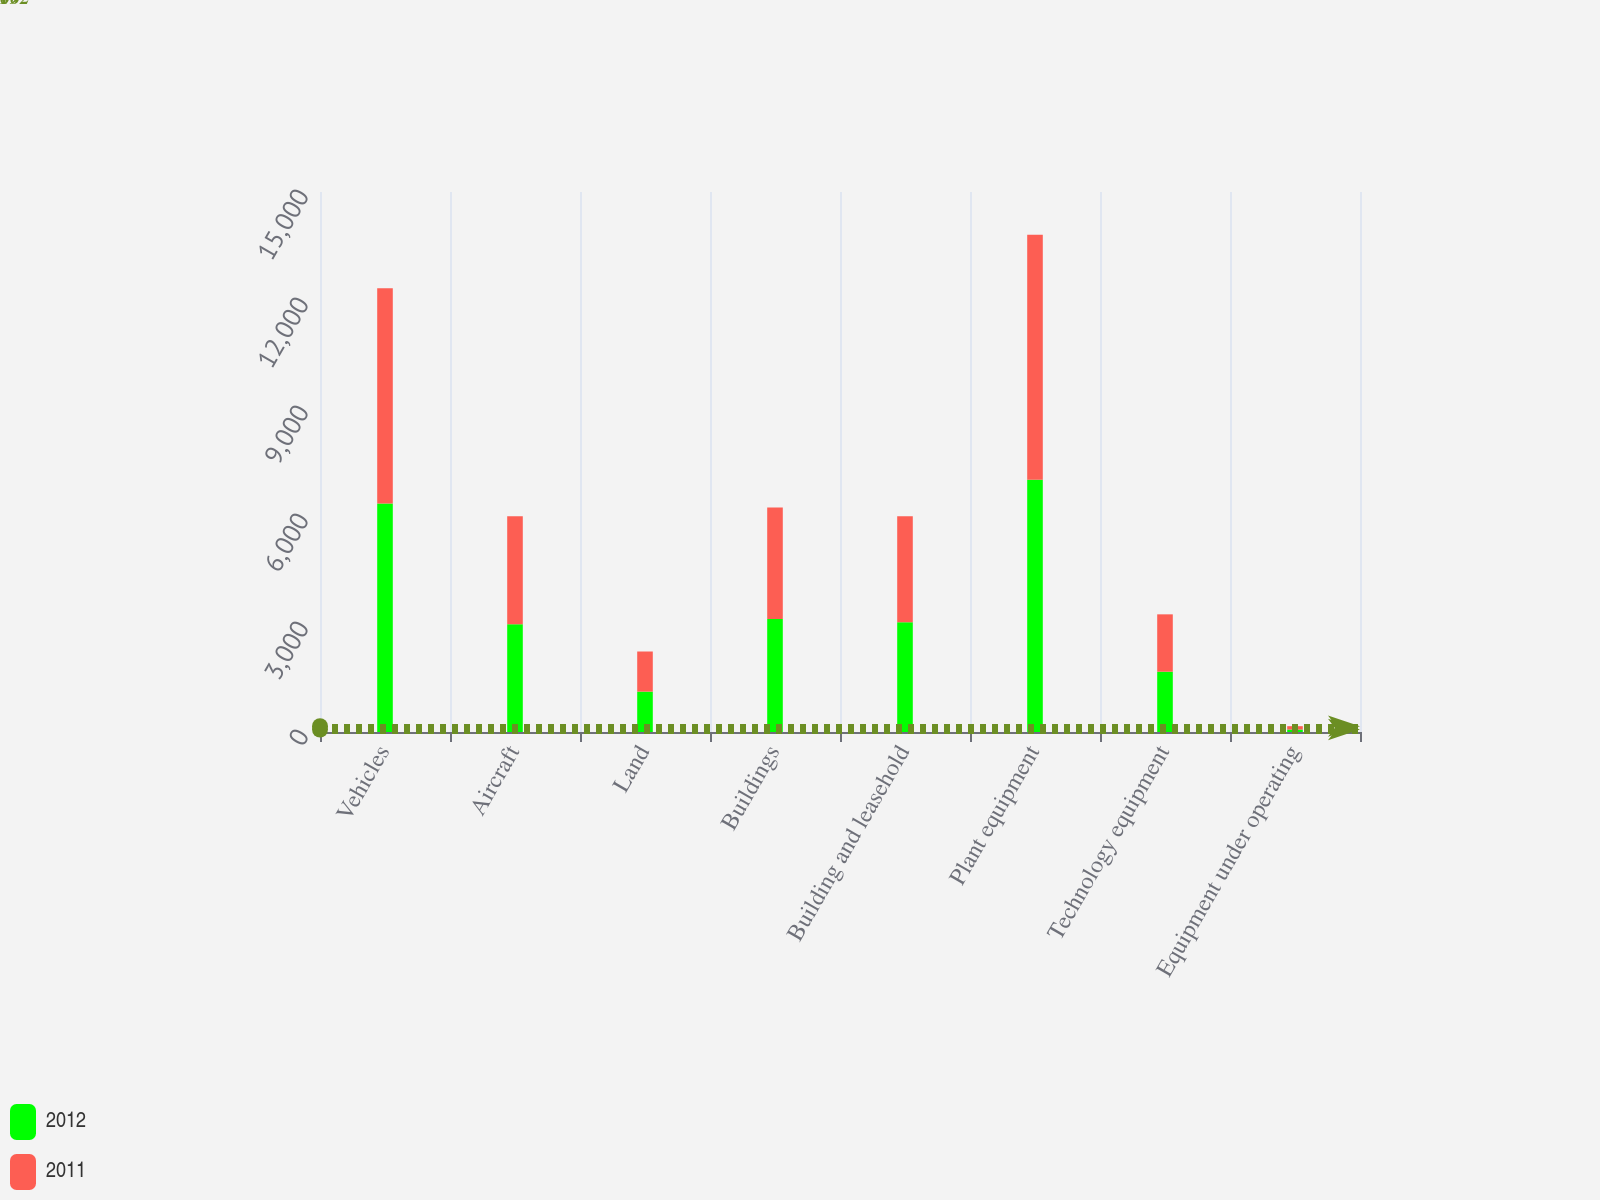<chart> <loc_0><loc_0><loc_500><loc_500><stacked_bar_chart><ecel><fcel>Vehicles<fcel>Aircraft<fcel>Land<fcel>Buildings<fcel>Building and leasehold<fcel>Plant equipment<fcel>Technology equipment<fcel>Equipment under operating<nl><fcel>2012<fcel>6344<fcel>2996<fcel>1122<fcel>3138<fcel>3049<fcel>7010<fcel>1675<fcel>69<nl><fcel>2011<fcel>5981<fcel>2996<fcel>1114<fcel>3095<fcel>2943<fcel>6803<fcel>1593<fcel>93<nl></chart> 